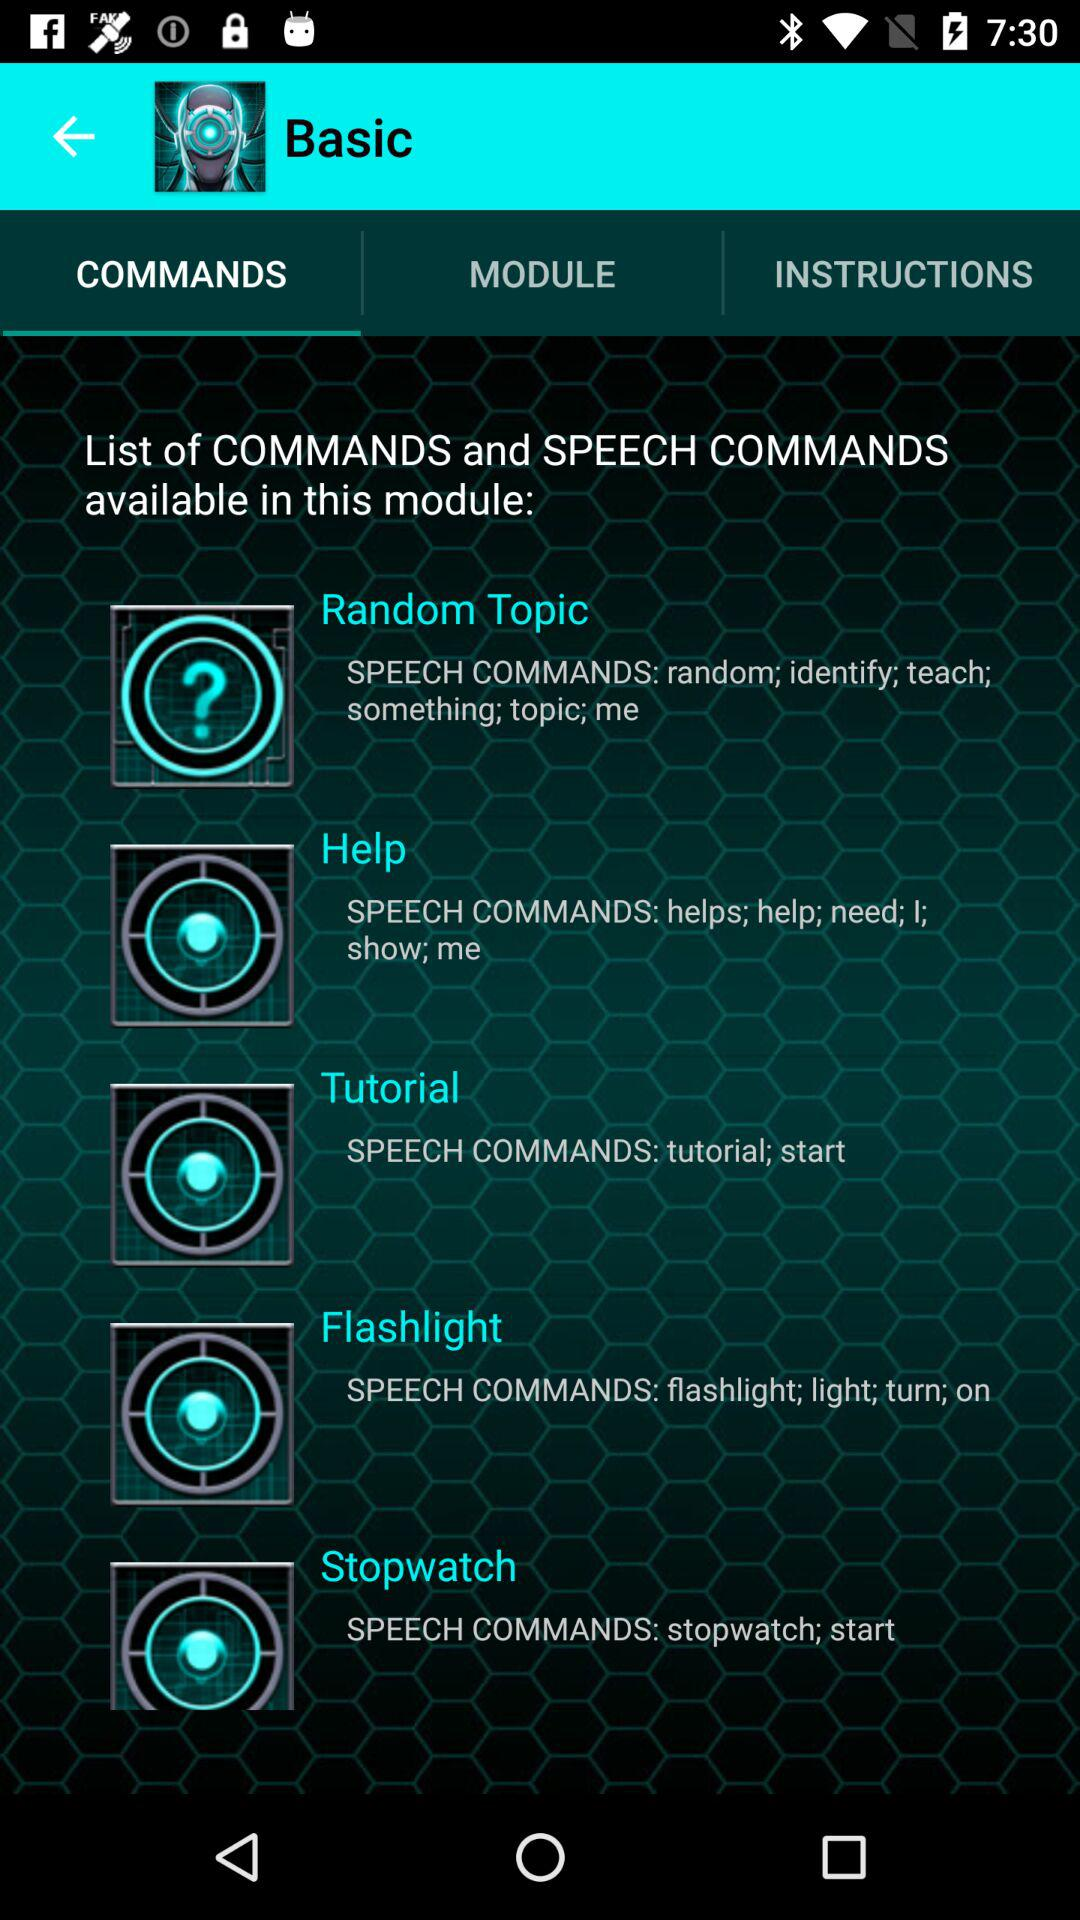What option is selected in "Basic"? The selected option is "COMMANDS". 